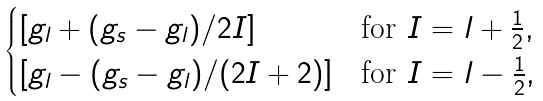<formula> <loc_0><loc_0><loc_500><loc_500>\begin{cases} [ g _ { l } + ( g _ { s } - g _ { l } ) / 2 I ] & \text {for $I=l+\frac{1}{2}$} , \\ [ g _ { l } - ( g _ { s } - g _ { l } ) / ( 2 I + 2 ) ] & \text {for $I=l-\frac{1}{2}$} , \end{cases}</formula> 